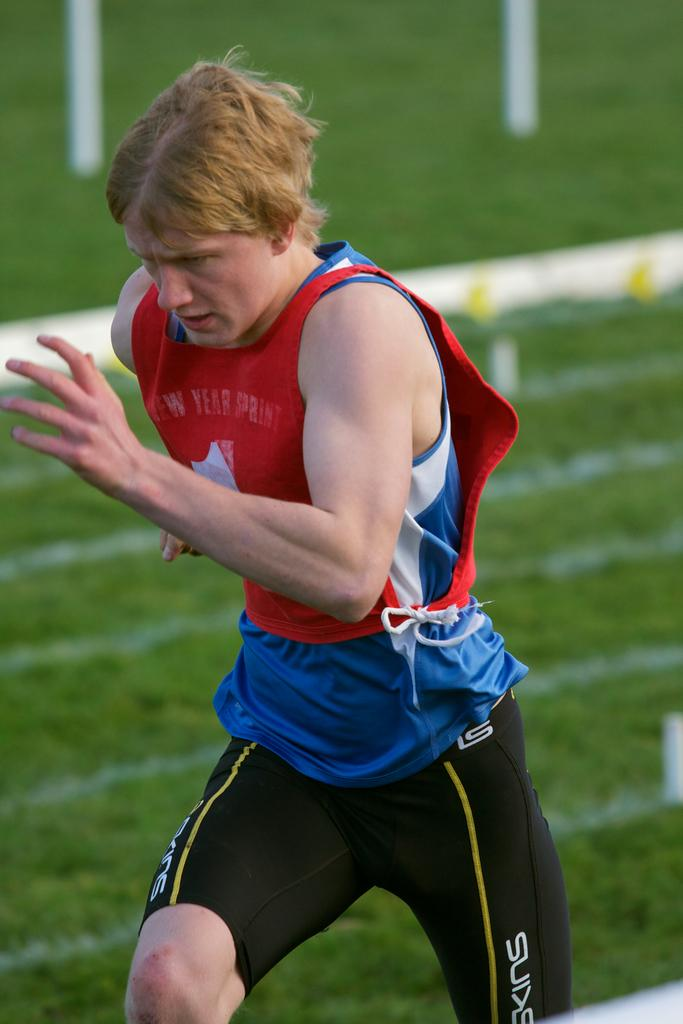<image>
Offer a succinct explanation of the picture presented. A sprinter has the word "year" on his red tank top as he runs. 